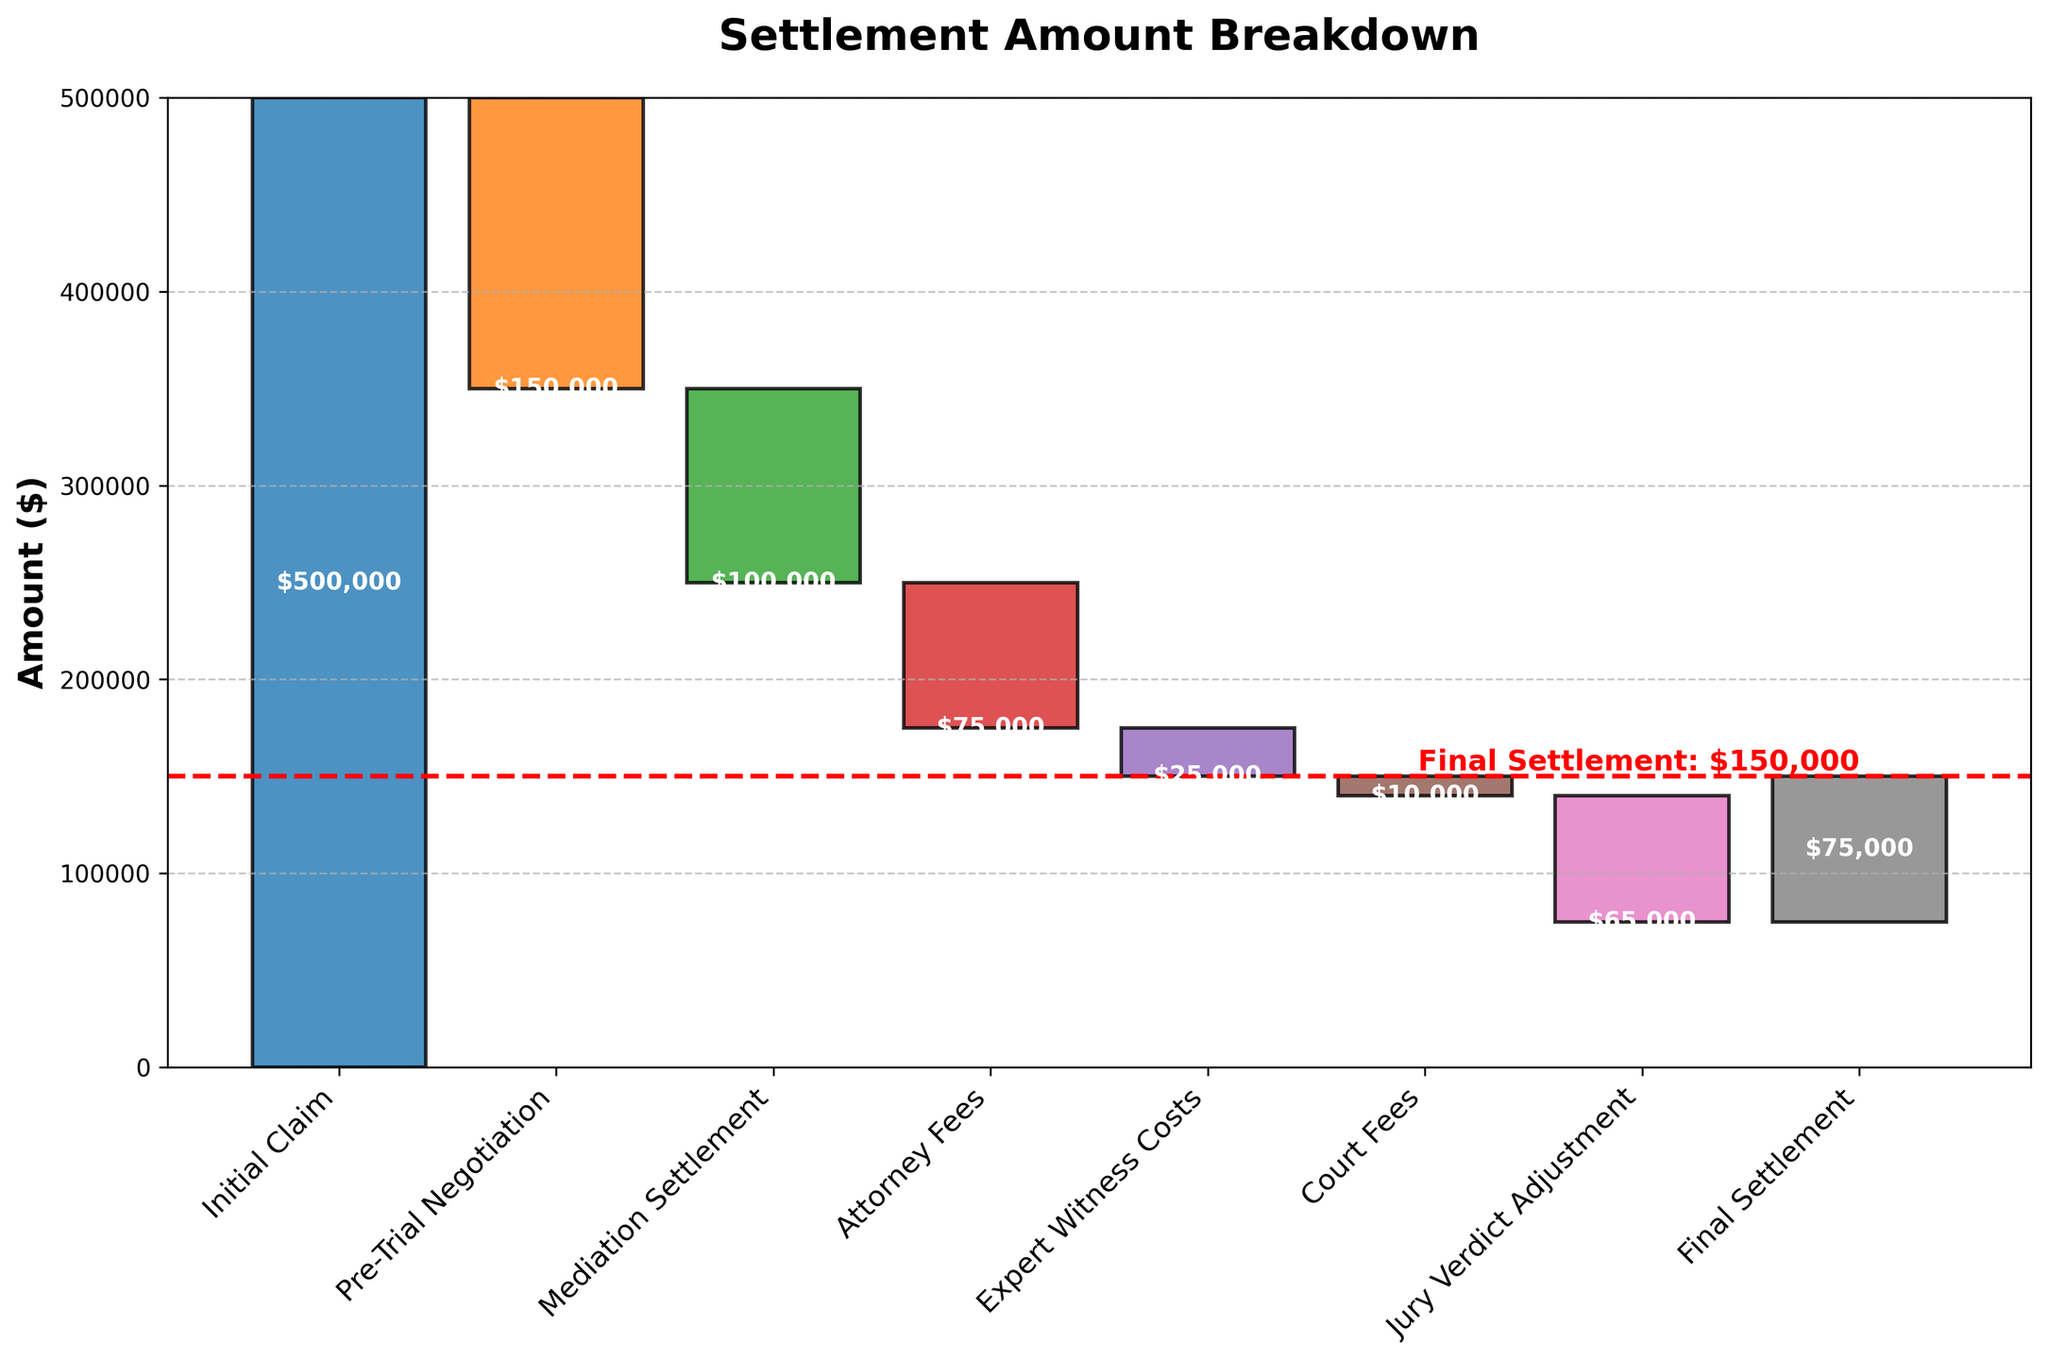What is the title of the chart? The title of the chart is displayed at the top and indicates the main subject of the chart. Here, it is located above the bars and reads "Settlement Amount Breakdown."
Answer: Settlement Amount Breakdown What is the final settlement amount? The final settlement amount can be found at the end of the cumulative line and is also marked by a red horizontal line with the amount displayed. The final amount is shown as $75,000.
Answer: $75,000 How much was deducted during the Pre-Trial Negotiation? The amount deducted during the Pre-Trial Negotiation is represented by the second bar and is labeled. It shows a deduction of $150,000.
Answer: $150,000 Which stage had a positive impact on the total settlement amount? By inspecting the heights of the bars, we find that only the Initial Claim bar is above the original baseline, representing an addition of $500,000. All other stages contribute to deductions.
Answer: Initial Claim What is the total of all the deductions combined? Identify all negative amounts and sum them: $150,000 (Pre-Trial Negotiation) + $100,000 (Mediation Settlement) + $75,000 (Attorney Fees) + $25,000 (Expert Witness Costs) + $10,000 (Court Fees) + $65,000 (Jury Verdict Adjustment). Total deductions = $150,000 + $100,000 + $75,000 + $25,000 + $10,000 + $65,000 = $425,000.
Answer: $425,000 What percentage of the initial claim was reduced by the jury verdict adjustment? Calculate the reduction due to the Jury Verdict Adjustment compared to the Initial Claim. Take the reduction amount ($65,000) and divide it by the Initial Claim ($500,000), then multiply by 100 to find the percentage: $(65,000/500,000) \times 100 = 13\%$.
Answer: 13% How does the pre-trial negotiation impact compare to attorney fees? Identify both stages and compare their impact by their amounts. Pre-Trial Negotiation deduction is $150,000, and Attorney Fees deduction is $75,000. The Pre-Trial Negotiation had a larger impact.
Answer: Pre-Trial Negotiation had a larger impact Which stage had the smallest impact on the settlement amount? Look for the stage with the smallest bar height. The Court Fees stage shows a deduction of $10,000, which is the smallest impact.
Answer: Court Fees How would the final settlement change if Mediation Settlement was not deducted? The Mediation Settlement deduction is $100,000. Adding this back to the final settlement ($75,000) results in $75,000 + $100,000 = $175,000.
Answer: $175,000 What amount of the deductions is attributed to expert witness costs and court fees combined? Combine the amounts of these two stages: $25,000 (Expert Witness Costs) + $10,000 (Court Fees) = $35,000.
Answer: $35,000 